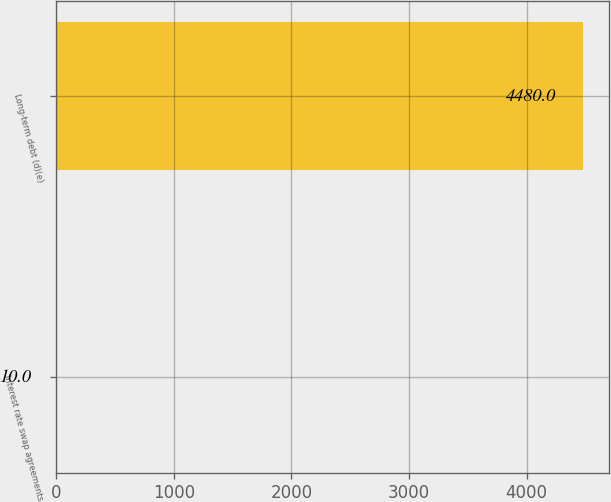Convert chart to OTSL. <chart><loc_0><loc_0><loc_500><loc_500><bar_chart><fcel>Interest rate swap agreements<fcel>Long-term debt (d)(e)<nl><fcel>10<fcel>4480<nl></chart> 